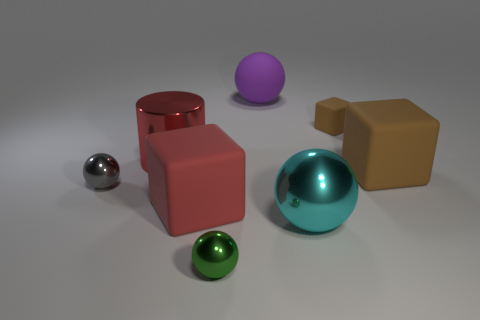Subtract all big blocks. How many blocks are left? 1 Subtract all red blocks. How many blocks are left? 2 Subtract 1 cylinders. How many cylinders are left? 0 Add 1 metallic spheres. How many objects exist? 9 Subtract all purple blocks. Subtract all yellow cylinders. How many blocks are left? 3 Subtract all yellow cylinders. How many purple spheres are left? 1 Subtract all cyan objects. Subtract all big cyan matte things. How many objects are left? 7 Add 5 big shiny cylinders. How many big shiny cylinders are left? 6 Add 7 big brown things. How many big brown things exist? 8 Subtract 0 purple blocks. How many objects are left? 8 